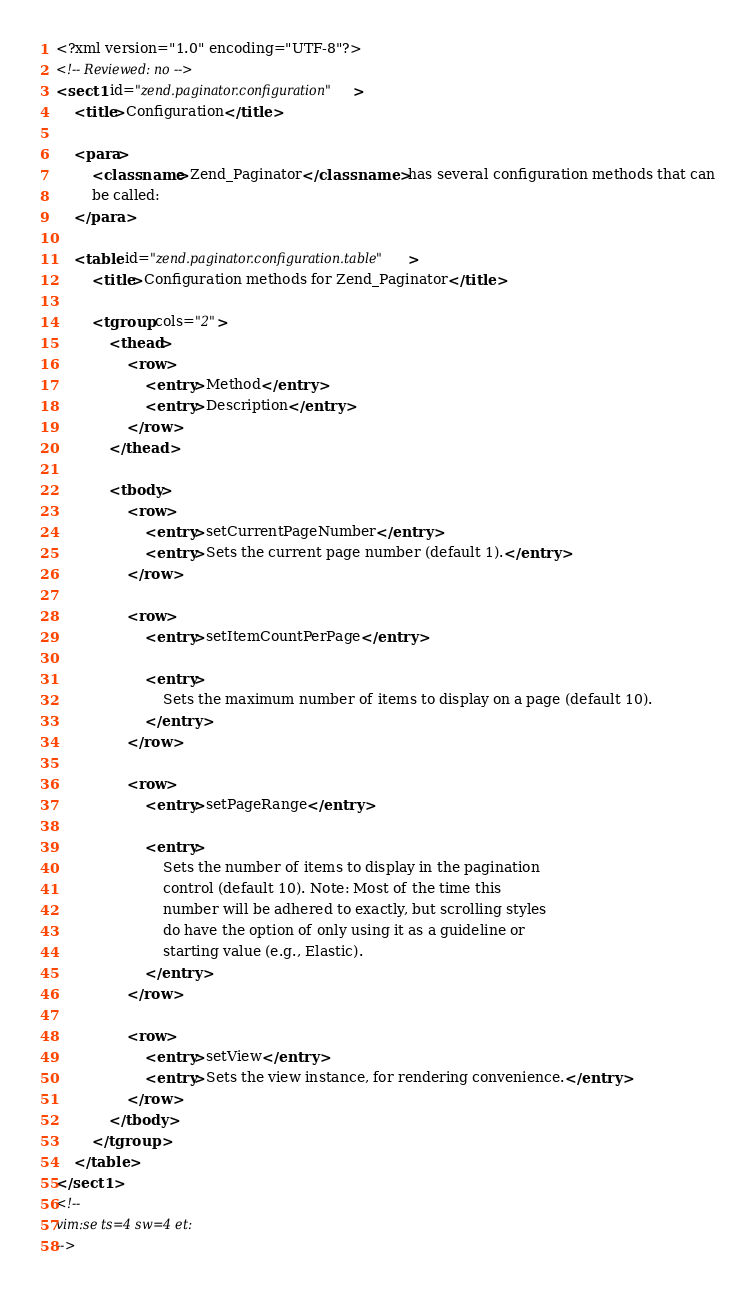Convert code to text. <code><loc_0><loc_0><loc_500><loc_500><_XML_><?xml version="1.0" encoding="UTF-8"?>
<!-- Reviewed: no -->
<sect1 id="zend.paginator.configuration">
    <title>Configuration</title>

    <para>
        <classname>Zend_Paginator</classname> has several configuration methods that can
        be called:
    </para>

    <table id="zend.paginator.configuration.table">
        <title>Configuration methods for Zend_Paginator</title>

        <tgroup cols="2">
            <thead>
                <row>
                    <entry>Method</entry>
                    <entry>Description</entry>
                </row>
            </thead>

            <tbody>
                <row>
                    <entry>setCurrentPageNumber</entry>
                    <entry>Sets the current page number (default 1).</entry>
                </row>

                <row>
                    <entry>setItemCountPerPage</entry>

                    <entry>
                        Sets the maximum number of items to display on a page (default 10).
                    </entry>
                </row>

                <row>
                    <entry>setPageRange</entry>

                    <entry>
                        Sets the number of items to display in the pagination
                        control (default 10). Note: Most of the time this
                        number will be adhered to exactly, but scrolling styles
                        do have the option of only using it as a guideline or
                        starting value (e.g., Elastic).
                    </entry>
                </row>

                <row>
                    <entry>setView</entry>
                    <entry>Sets the view instance, for rendering convenience.</entry>
                </row>
            </tbody>
        </tgroup>
    </table>
</sect1>
<!--
vim:se ts=4 sw=4 et:
-->
</code> 